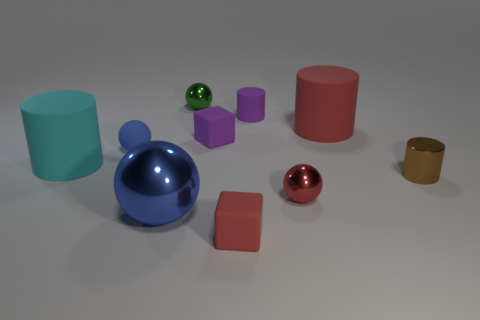What is the material of the tiny blue thing that is the same shape as the green shiny object?
Your response must be concise. Rubber. Do the metal object that is in front of the red ball and the tiny red block have the same size?
Provide a succinct answer. No. Are there fewer big blue metallic objects that are right of the brown metallic object than balls?
Your answer should be very brief. Yes. What is the material of the red block that is the same size as the brown cylinder?
Your answer should be compact. Rubber. How many large objects are either yellow shiny objects or cubes?
Provide a short and direct response. 0. What number of things are either small rubber blocks behind the large cyan cylinder or spheres that are in front of the big cyan rubber object?
Your response must be concise. 3. Are there fewer small blocks than tiny metal objects?
Keep it short and to the point. Yes. There is a blue rubber thing that is the same size as the brown thing; what is its shape?
Keep it short and to the point. Sphere. How many other things are there of the same color as the large metal ball?
Provide a succinct answer. 1. How many big yellow matte balls are there?
Make the answer very short. 0. 